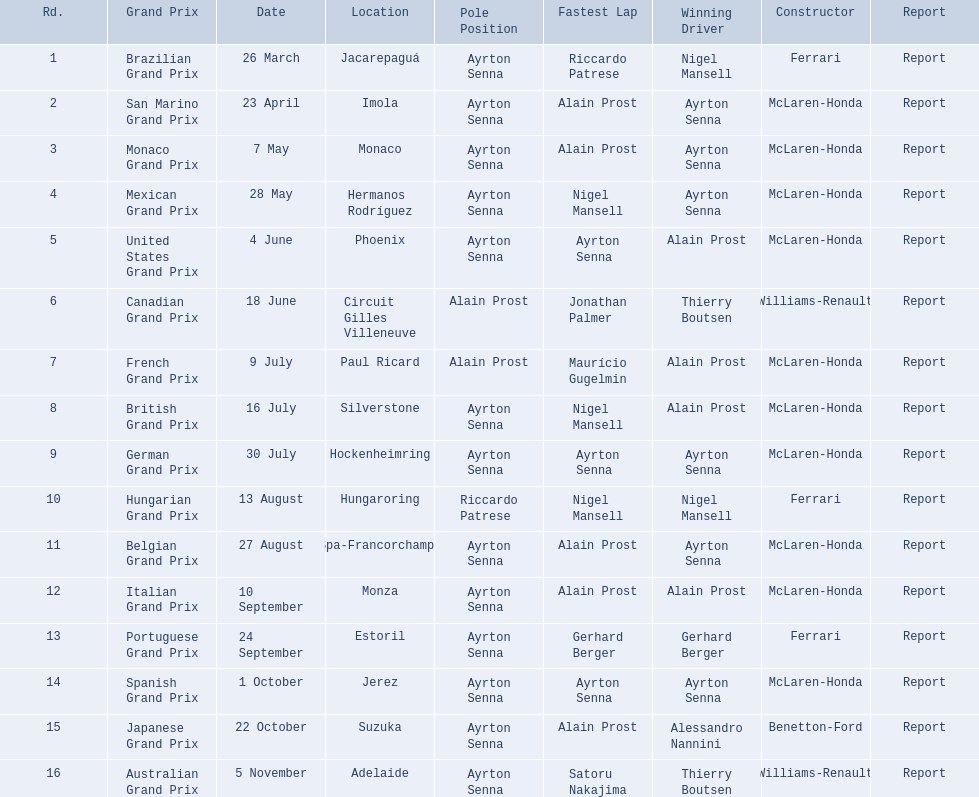Who were the builders involved in the 1989 formula one season? Ferrari, McLaren-Honda, McLaren-Honda, McLaren-Honda, McLaren-Honda, Williams-Renault, McLaren-Honda, McLaren-Honda, McLaren-Honda, Ferrari, McLaren-Honda, McLaren-Honda, Ferrari, McLaren-Honda, Benetton-Ford, Williams-Renault. When was benetton ford recognized as the constructor? 22 October. What event took place on october 22nd during that season? Japanese Grand Prix. 